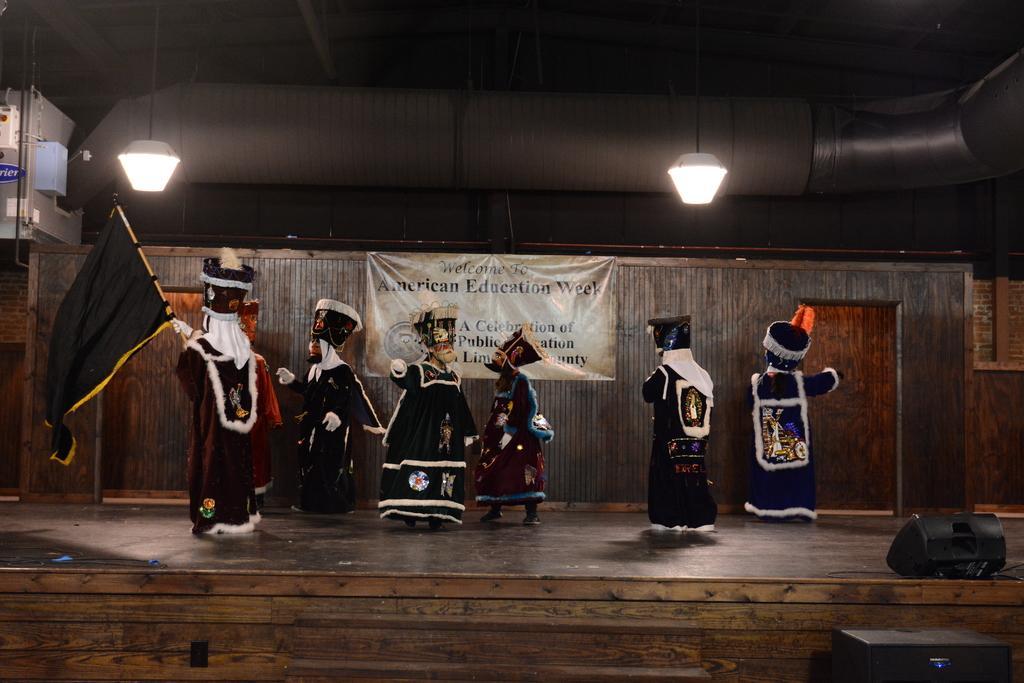In one or two sentences, can you explain what this image depicts? In this image I can see a stage and on it I can see few people are standing and wearing black costumes. On the left side of the image I can see one person is holding a black flag. On the right side of the image I can see two black colour things and on the top side of the image I can see two lights. On the left side of the image I can see a box and on it I can see something is written. In the background I can see a banner and on it I can see something is written. 